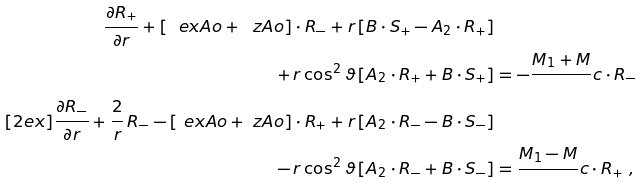<formula> <loc_0><loc_0><loc_500><loc_500>\frac { \partial R _ { + } } { \partial r } + \left [ \ e x A o + \ z A o \right ] \cdot R _ { - } + r \left [ B \cdot S _ { + } - A _ { 2 } \cdot R _ { + } \right ] & \\ + \, r \cos ^ { 2 } \vartheta \left [ A _ { 2 } \cdot R _ { + } + B \cdot S _ { + } \right ] & = - \frac { M _ { 1 } + M } { } c \cdot R _ { - } \\ [ 2 e x ] \frac { \partial R _ { - } } { \partial r } + \frac { 2 } { r } \, R _ { - } - \left [ \ e x A o + \ z A o \right ] \cdot R _ { + } + r \left [ A _ { 2 } \cdot R _ { - } - B \cdot S _ { - } \right ] & \\ - \, r \cos ^ { 2 } \vartheta \left [ A _ { 2 } \cdot R _ { - } + B \cdot S _ { - } \right ] & = \frac { M _ { 1 } - M } { } c \cdot R _ { + } \ ,</formula> 